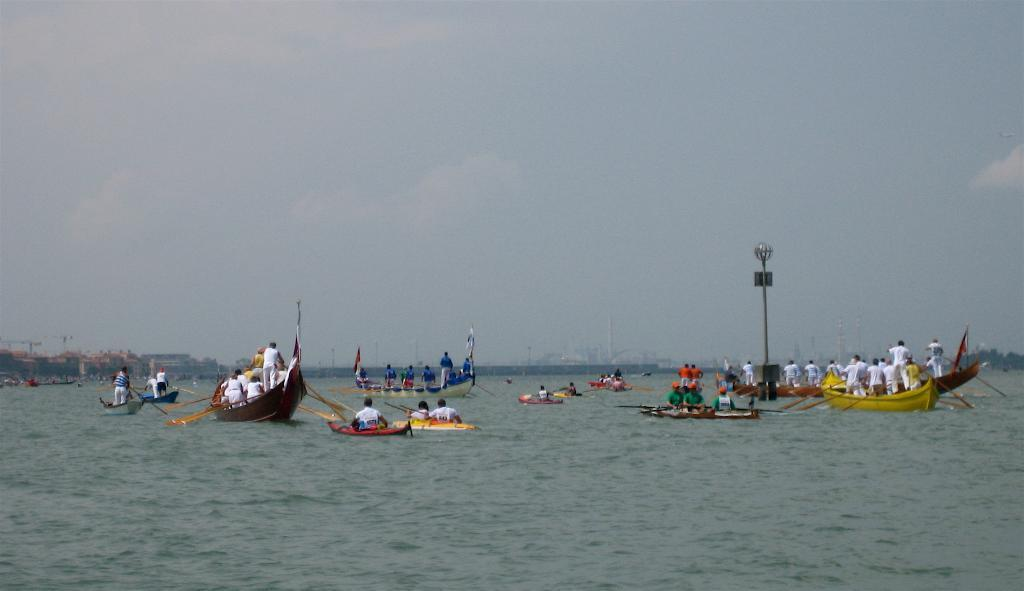What are the people in the image doing? There are persons in the boats in the image. Where are the boats located? The boats are on the water. What can be seen in the background of the image? There is sky visible in the image, and clouds are present in the sky. What is in the middle of the water? There is a pole in the middle of the water. What type of cracker is being used as a paddle for the boats in the image? There is no cracker present in the image, and no indication that the boats are being propelled by crackers. 